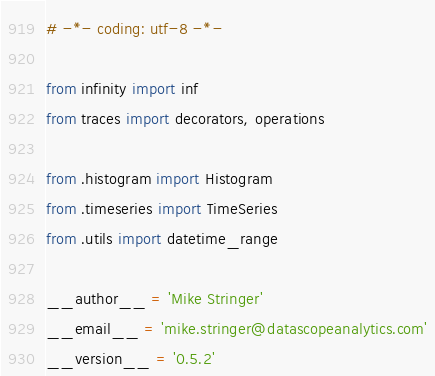<code> <loc_0><loc_0><loc_500><loc_500><_Python_># -*- coding: utf-8 -*-

from infinity import inf
from traces import decorators, operations

from .histogram import Histogram
from .timeseries import TimeSeries
from .utils import datetime_range

__author__ = 'Mike Stringer'
__email__ = 'mike.stringer@datascopeanalytics.com'
__version__ = '0.5.2'
</code> 